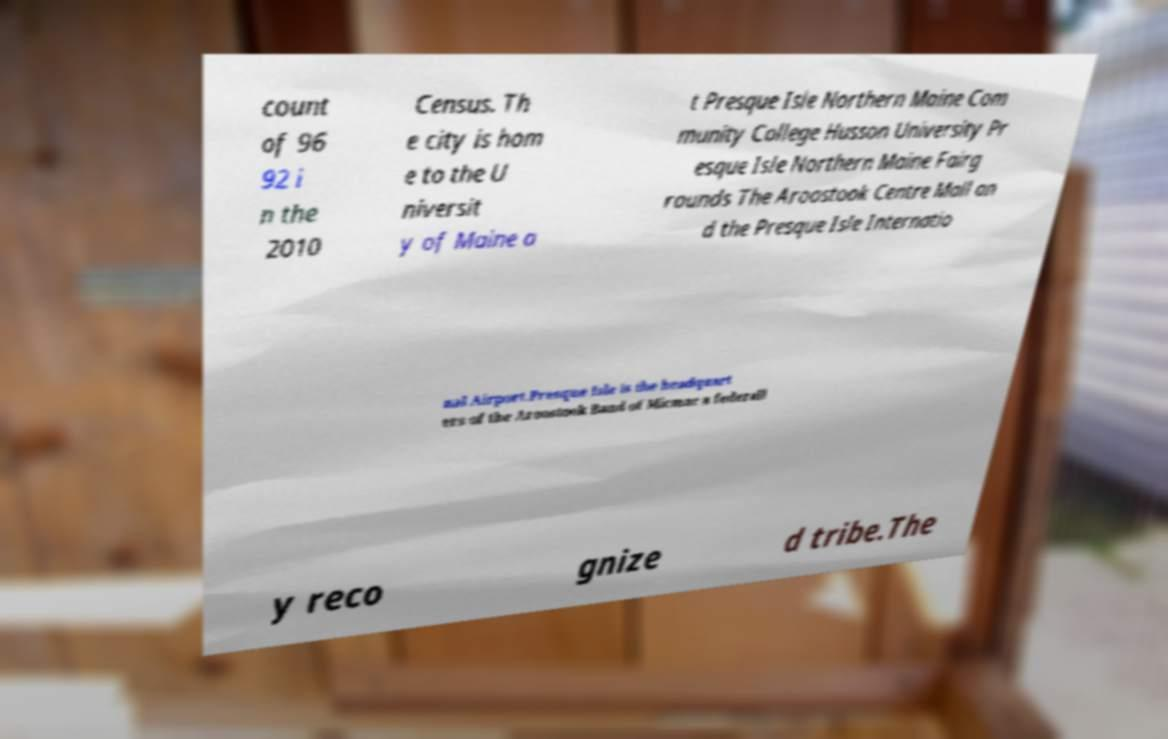I need the written content from this picture converted into text. Can you do that? count of 96 92 i n the 2010 Census. Th e city is hom e to the U niversit y of Maine a t Presque Isle Northern Maine Com munity College Husson University Pr esque Isle Northern Maine Fairg rounds The Aroostook Centre Mall an d the Presque Isle Internatio nal Airport.Presque Isle is the headquart ers of the Aroostook Band of Micmac a federall y reco gnize d tribe.The 